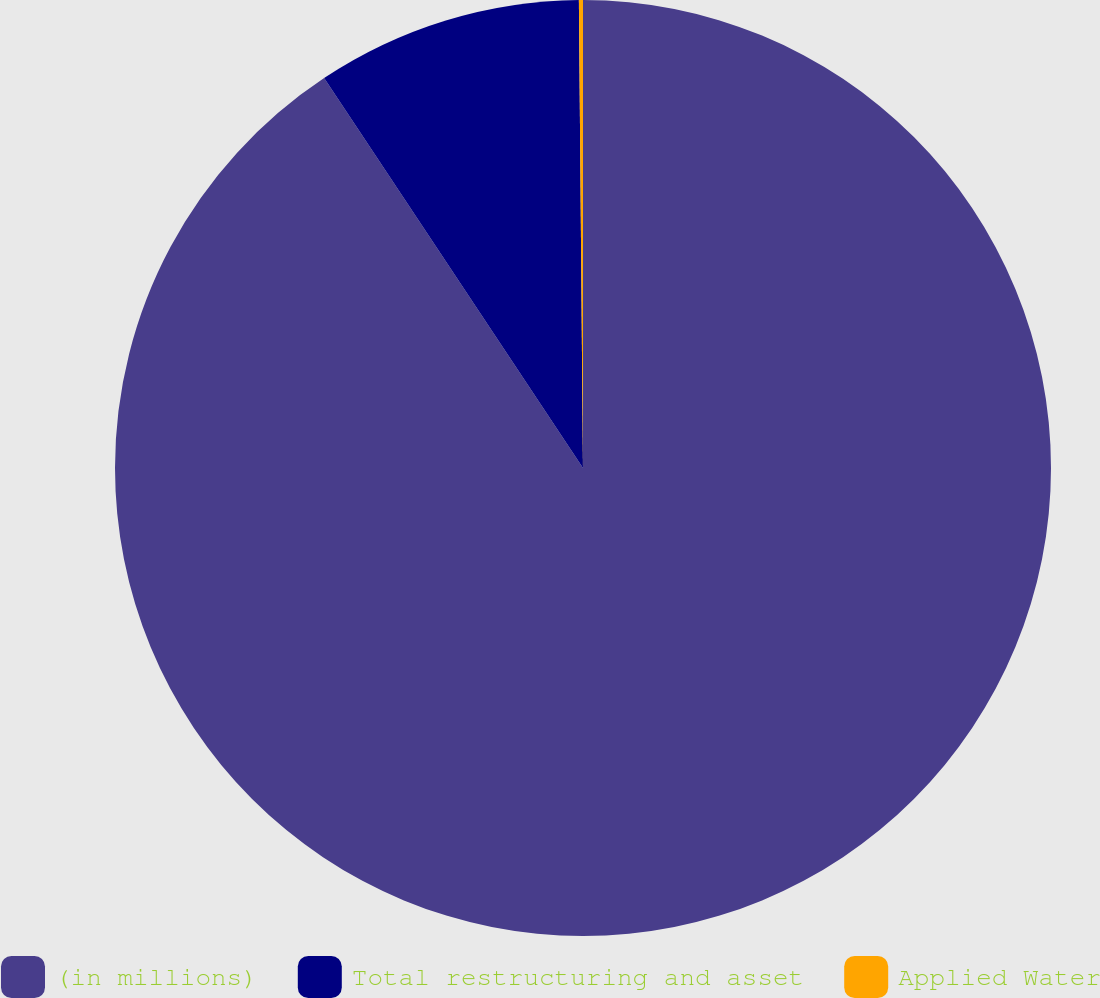Convert chart. <chart><loc_0><loc_0><loc_500><loc_500><pie_chart><fcel>(in millions)<fcel>Total restructuring and asset<fcel>Applied Water<nl><fcel>90.68%<fcel>9.19%<fcel>0.14%<nl></chart> 